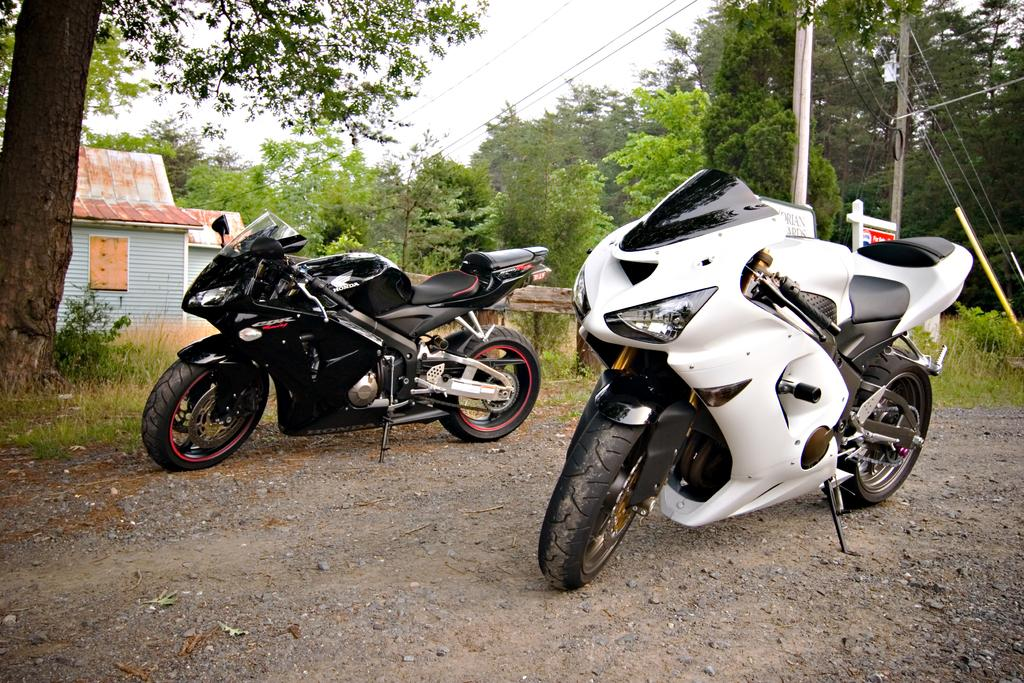What vehicles are present on the ground in the image? There are two motorbikes on the ground in the image. What type of natural environment is visible in the image? There are many trees visible in the image. What structures can be seen in the image? There are poles and boards in the image. What type of building is present in the image? There is a house in the image. What is visible in the background of the image? The sky is visible in the background of the image. What type of pan is being used to cook food in the image? There is no pan or cooking activity present in the image. How many trains can be seen passing by in the image? There are no trains visible in the image. 